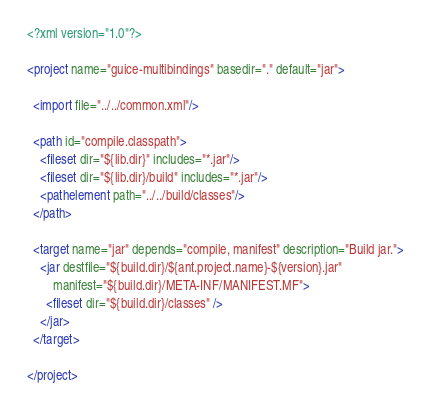<code> <loc_0><loc_0><loc_500><loc_500><_XML_><?xml version="1.0"?>

<project name="guice-multibindings" basedir="." default="jar">

  <import file="../../common.xml"/>
  
  <path id="compile.classpath">
    <fileset dir="${lib.dir}" includes="*.jar"/>
    <fileset dir="${lib.dir}/build" includes="*.jar"/>
    <pathelement path="../../build/classes"/>
  </path>

  <target name="jar" depends="compile, manifest" description="Build jar.">
    <jar destfile="${build.dir}/${ant.project.name}-${version}.jar"
        manifest="${build.dir}/META-INF/MANIFEST.MF">
      <fileset dir="${build.dir}/classes" />
    </jar>
  </target>

</project>
</code> 